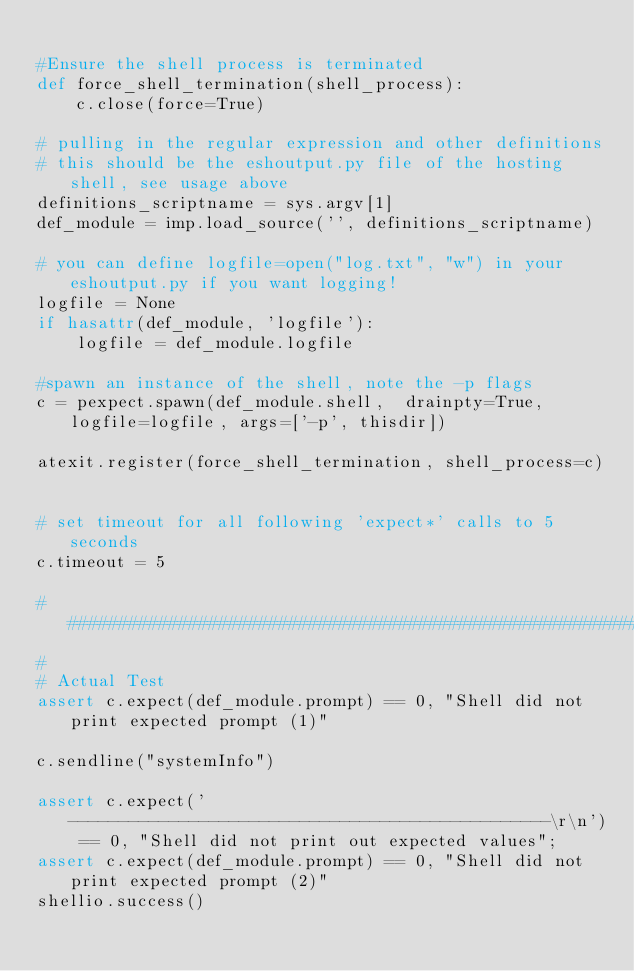Convert code to text. <code><loc_0><loc_0><loc_500><loc_500><_Python_>
#Ensure the shell process is terminated
def force_shell_termination(shell_process):
	c.close(force=True)

# pulling in the regular expression and other definitions
# this should be the eshoutput.py file of the hosting shell, see usage above
definitions_scriptname = sys.argv[1]
def_module = imp.load_source('', definitions_scriptname)

# you can define logfile=open("log.txt", "w") in your eshoutput.py if you want logging!
logfile = None
if hasattr(def_module, 'logfile'):
    logfile = def_module.logfile

#spawn an instance of the shell, note the -p flags
c = pexpect.spawn(def_module.shell,  drainpty=True, logfile=logfile, args=['-p', thisdir])

atexit.register(force_shell_termination, shell_process=c)


# set timeout for all following 'expect*' calls to 5 seconds
c.timeout = 5 

#############################################################################
#
# Actual Test
assert c.expect(def_module.prompt) == 0, "Shell did not print expected prompt (1)"

c.sendline("systemInfo")

assert c.expect('------------------------------------------------\r\n') == 0, "Shell did not print out expected values";
assert c.expect(def_module.prompt) == 0, "Shell did not print expected prompt (2)"
shellio.success()
</code> 